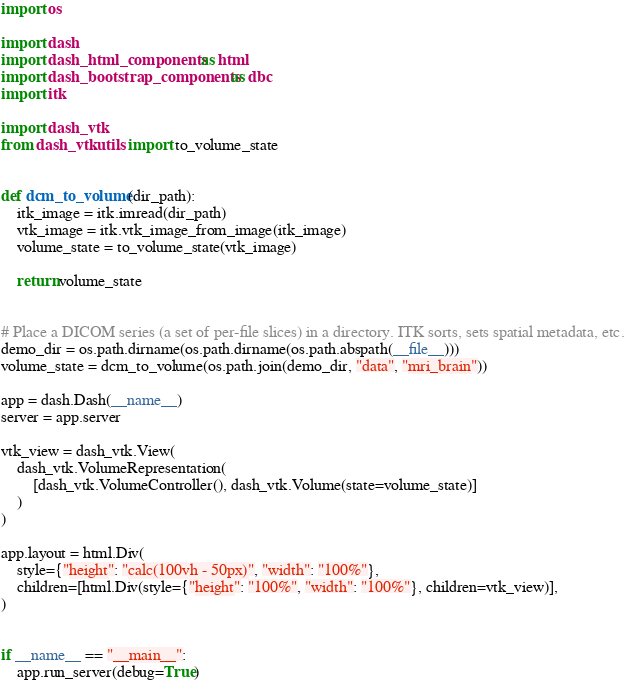<code> <loc_0><loc_0><loc_500><loc_500><_Python_>import os

import dash
import dash_html_components as html
import dash_bootstrap_components as dbc
import itk

import dash_vtk
from dash_vtk.utils import to_volume_state


def dcm_to_volume(dir_path):
    itk_image = itk.imread(dir_path)
    vtk_image = itk.vtk_image_from_image(itk_image)
    volume_state = to_volume_state(vtk_image)

    return volume_state


# Place a DICOM series (a set of per-file slices) in a directory. ITK sorts, sets spatial metadata, etc.
demo_dir = os.path.dirname(os.path.dirname(os.path.abspath(__file__)))
volume_state = dcm_to_volume(os.path.join(demo_dir, "data", "mri_brain"))

app = dash.Dash(__name__)
server = app.server

vtk_view = dash_vtk.View(
    dash_vtk.VolumeRepresentation(
        [dash_vtk.VolumeController(), dash_vtk.Volume(state=volume_state)]
    )
)

app.layout = html.Div(
    style={"height": "calc(100vh - 50px)", "width": "100%"},
    children=[html.Div(style={"height": "100%", "width": "100%"}, children=vtk_view)],
)


if __name__ == "__main__":
    app.run_server(debug=True)
</code> 